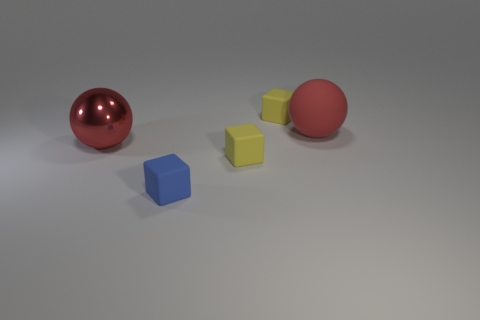Subtract all tiny blue rubber cubes. How many cubes are left? 2 Subtract all blue blocks. How many blocks are left? 2 Subtract 0 cyan balls. How many objects are left? 5 Subtract all balls. How many objects are left? 3 Subtract 2 blocks. How many blocks are left? 1 Subtract all yellow spheres. Subtract all red cylinders. How many spheres are left? 2 Subtract all brown spheres. How many yellow blocks are left? 2 Subtract all spheres. Subtract all small yellow rubber blocks. How many objects are left? 1 Add 4 blue rubber blocks. How many blue rubber blocks are left? 5 Add 1 small gray matte cylinders. How many small gray matte cylinders exist? 1 